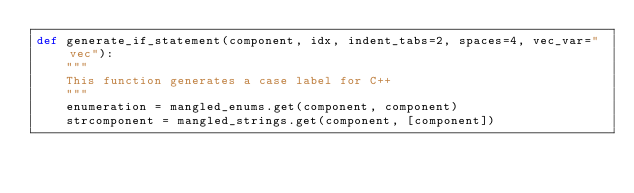<code> <loc_0><loc_0><loc_500><loc_500><_Python_>def generate_if_statement(component, idx, indent_tabs=2, spaces=4, vec_var="vec"):
    """
    This function generates a case label for C++
    """
    enumeration = mangled_enums.get(component, component)
    strcomponent = mangled_strings.get(component, [component])</code> 